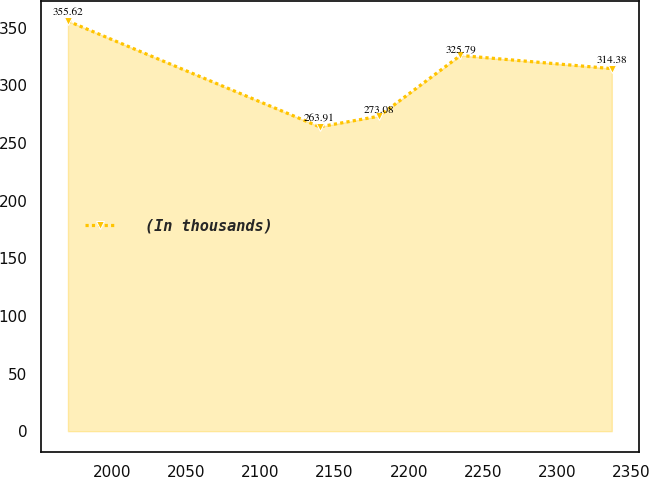<chart> <loc_0><loc_0><loc_500><loc_500><line_chart><ecel><fcel>(In thousands)<nl><fcel>1970.32<fcel>355.62<nl><fcel>2139.97<fcel>263.91<nl><fcel>2179.91<fcel>273.08<nl><fcel>2234.89<fcel>325.79<nl><fcel>2336.98<fcel>314.38<nl></chart> 